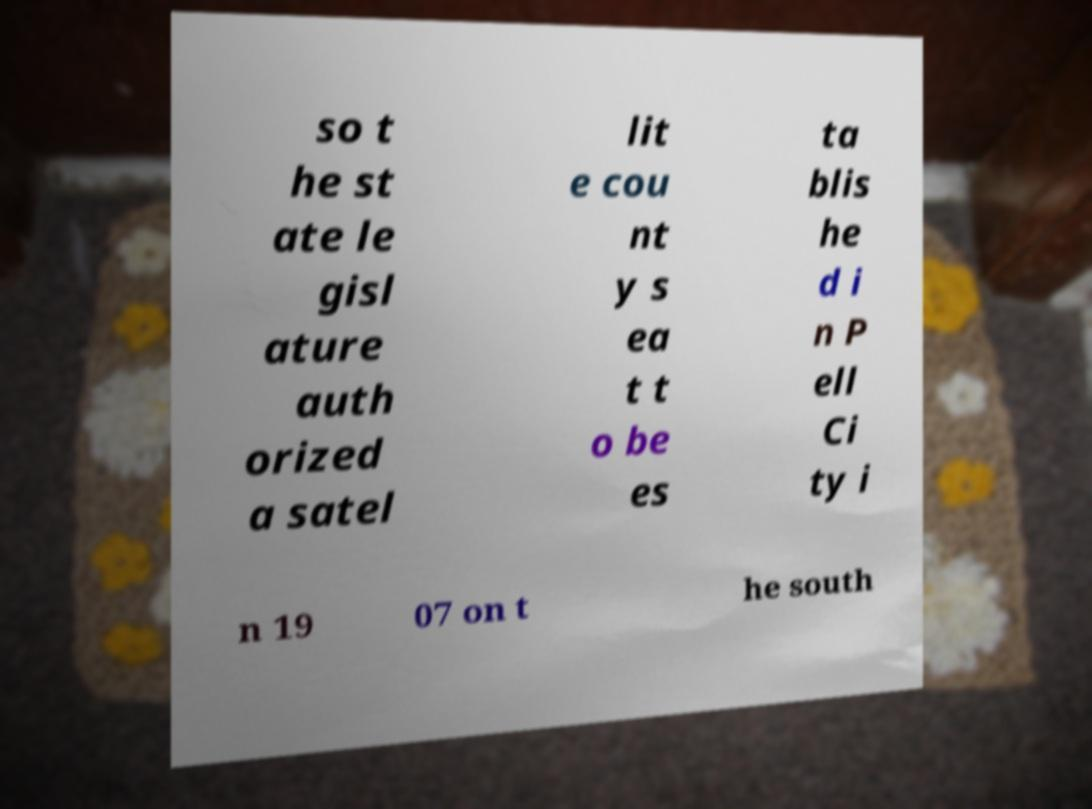Could you assist in decoding the text presented in this image and type it out clearly? so t he st ate le gisl ature auth orized a satel lit e cou nt y s ea t t o be es ta blis he d i n P ell Ci ty i n 19 07 on t he south 